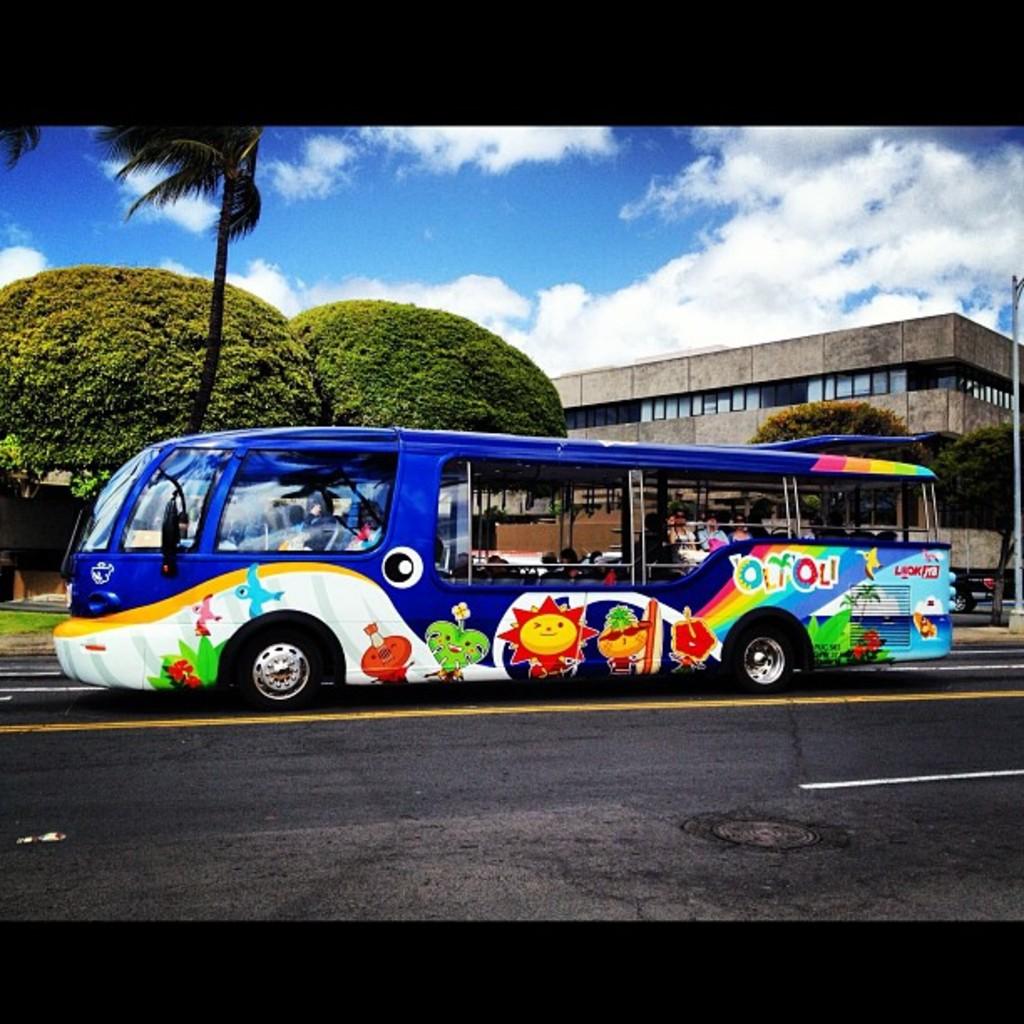What plant takes the shape of a letter on the side of the bus?
Your response must be concise. Palm tree. 